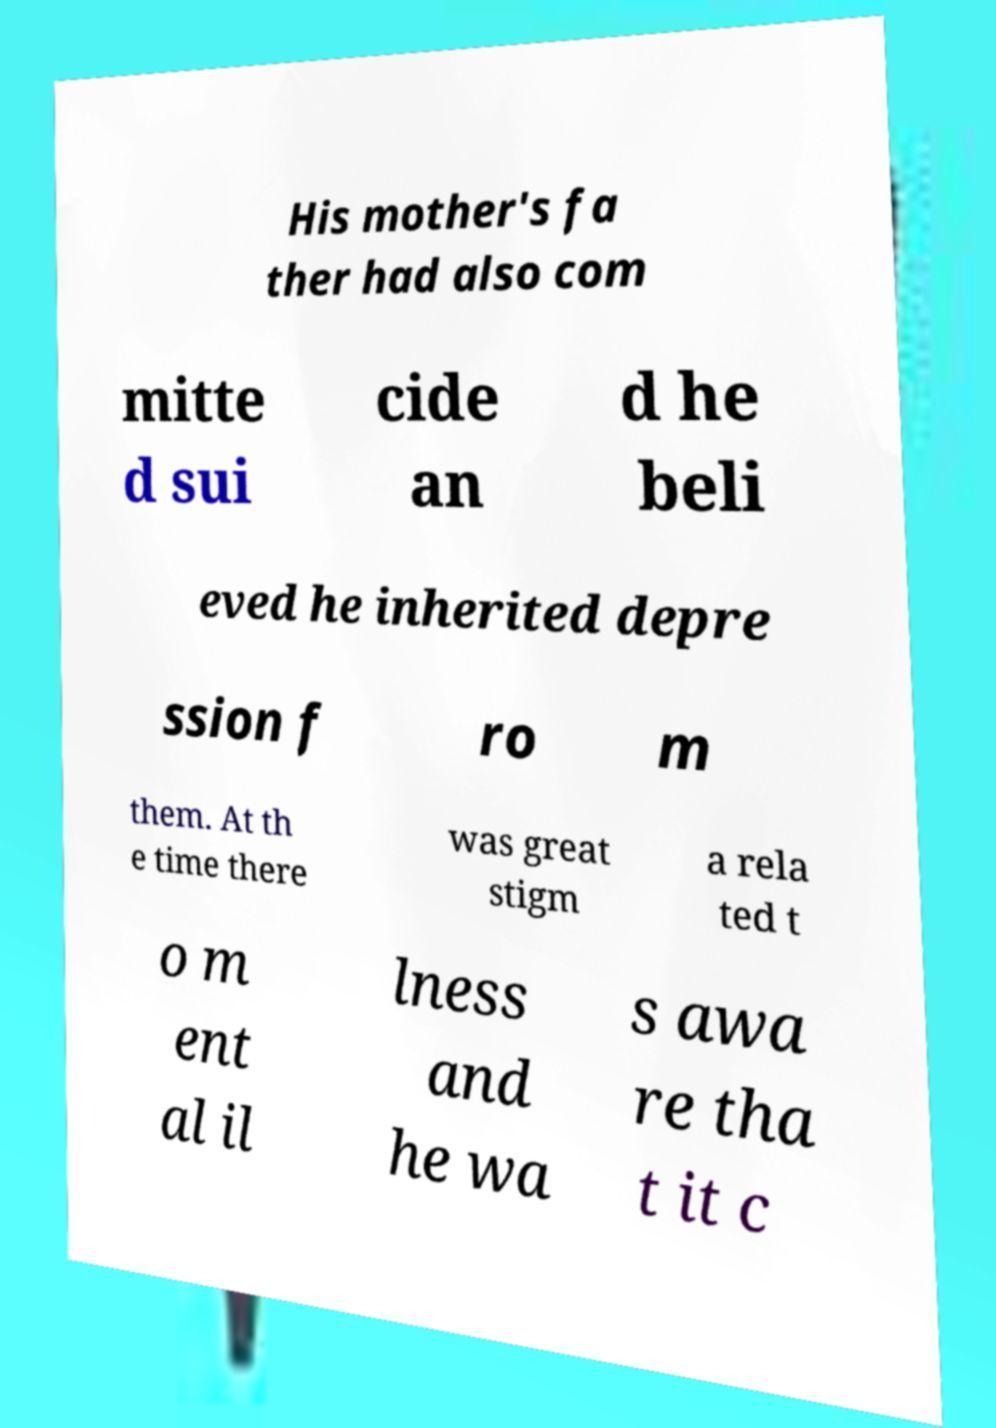I need the written content from this picture converted into text. Can you do that? His mother's fa ther had also com mitte d sui cide an d he beli eved he inherited depre ssion f ro m them. At th e time there was great stigm a rela ted t o m ent al il lness and he wa s awa re tha t it c 